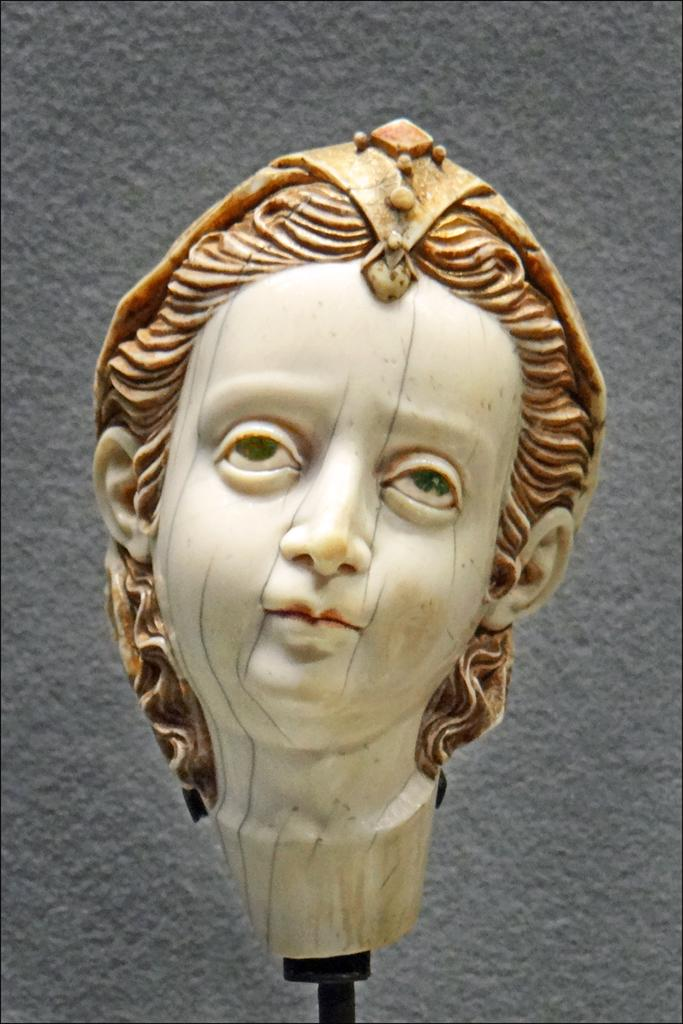What is the main subject of the image? There is a sculpture in the image. How is the sculpture positioned in the image? The sculpture is on a stand. What can be seen behind the sculpture in the image? There is a wall visible behind the sculpture. What color is the flesh of the sculpture in the image? There is no mention of flesh or color in the provided facts, as the sculpture's material and color are not specified. 